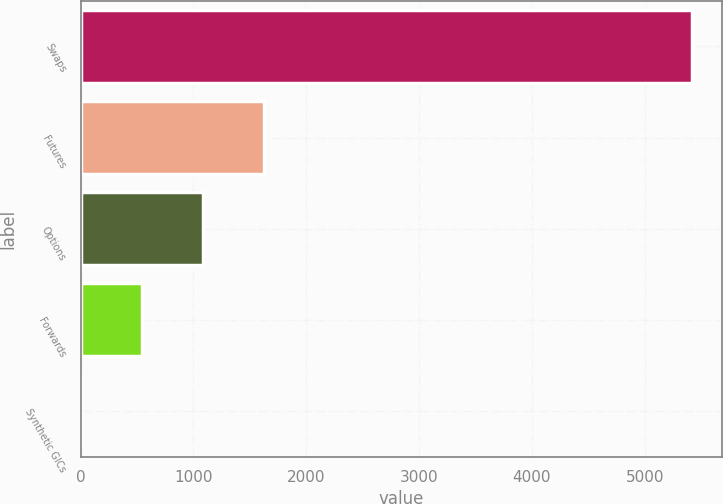<chart> <loc_0><loc_0><loc_500><loc_500><bar_chart><fcel>Swaps<fcel>Futures<fcel>Options<fcel>Forwards<fcel>Synthetic GICs<nl><fcel>5415<fcel>1625.2<fcel>1083.8<fcel>542.4<fcel>1<nl></chart> 